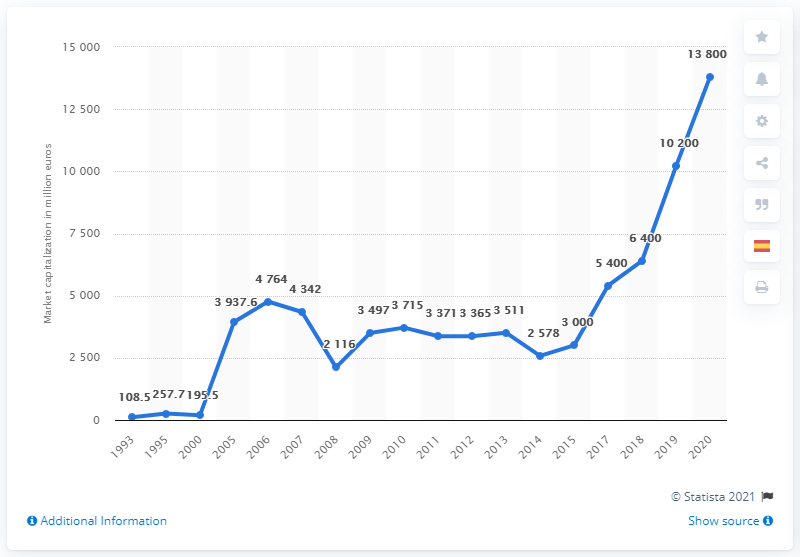List a handful of essential elements in this visual. In 2020, the Puma Group had a global market capitalization of approximately 13,800. 